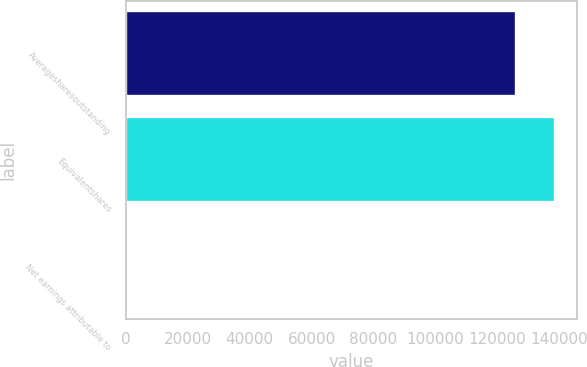Convert chart to OTSL. <chart><loc_0><loc_0><loc_500><loc_500><bar_chart><fcel>Averagesharesoutstanding<fcel>Equivalentshares<fcel>Net earnings attributable to<nl><fcel>126132<fcel>138745<fcel>1.75<nl></chart> 